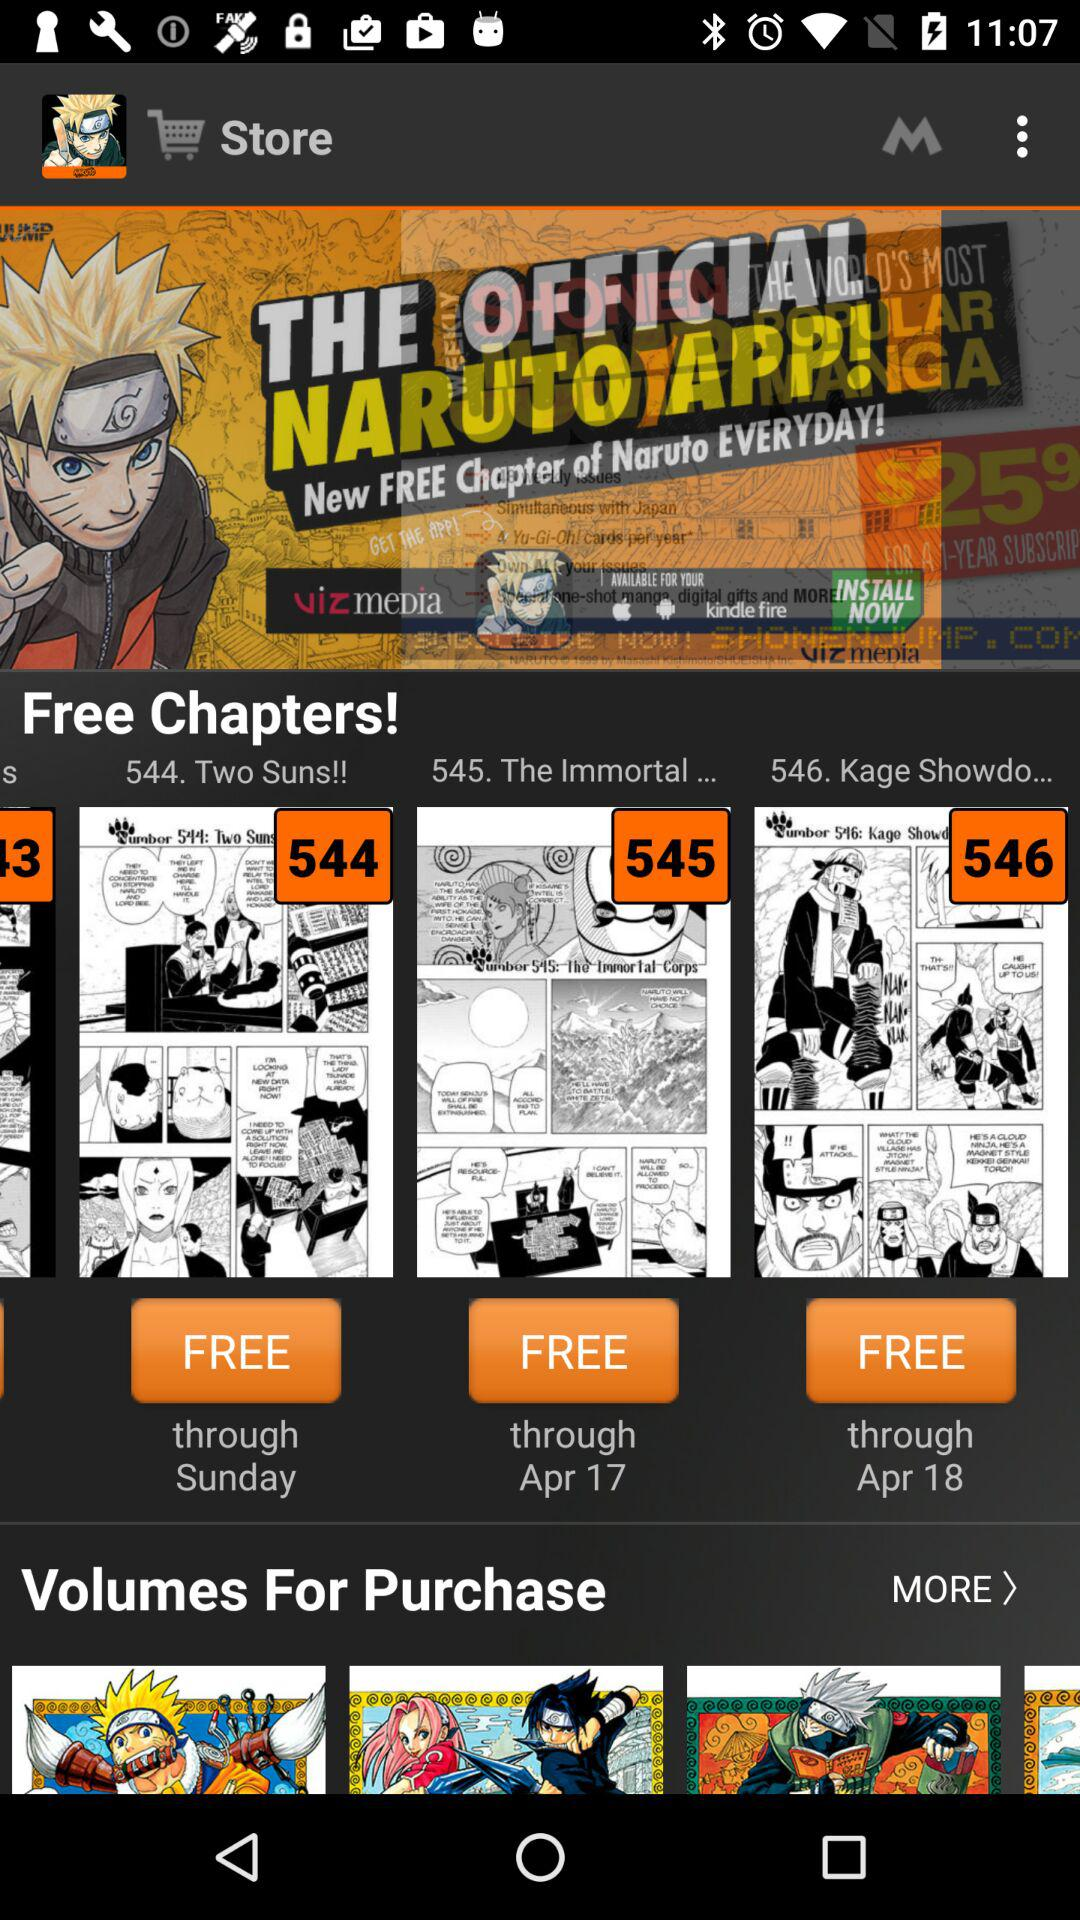Through what date is the chapter "The Immortal..." free? The date is April 17. 